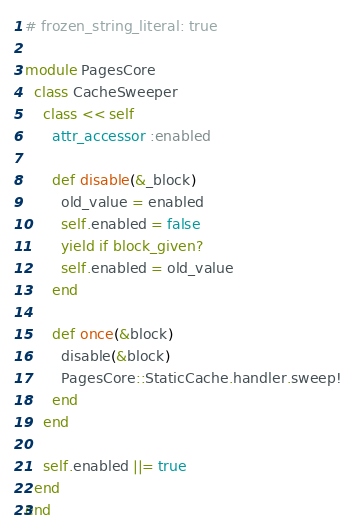<code> <loc_0><loc_0><loc_500><loc_500><_Ruby_># frozen_string_literal: true

module PagesCore
  class CacheSweeper
    class << self
      attr_accessor :enabled

      def disable(&_block)
        old_value = enabled
        self.enabled = false
        yield if block_given?
        self.enabled = old_value
      end

      def once(&block)
        disable(&block)
        PagesCore::StaticCache.handler.sweep!
      end
    end

    self.enabled ||= true
  end
end
</code> 